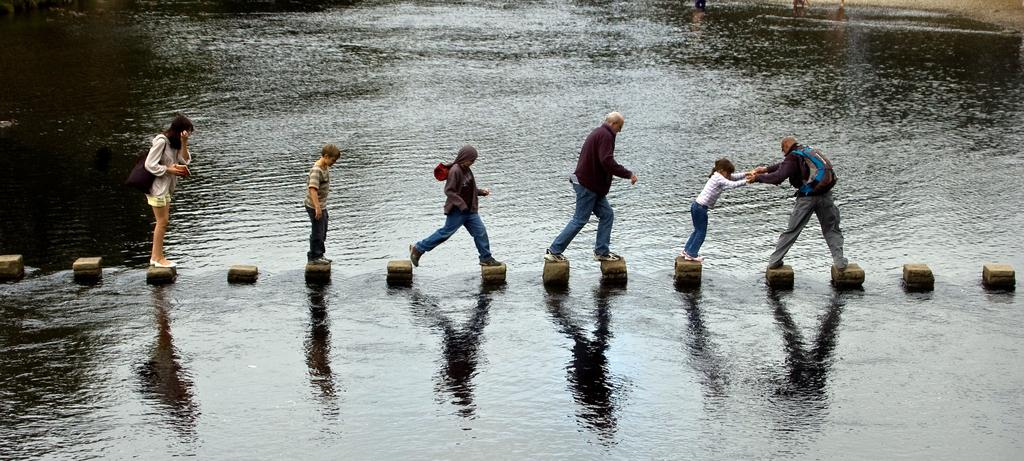How many people are in the image? There are persons in the image, but the exact number is not specified. What are the persons doing in the image? The persons are crossing water in the image. How are the persons crossing the water? The persons are using bricks arranged in the middle of the water to cross. What type of boundary can be seen in the image? There is no boundary present in the image; it features persons crossing water using bricks. What emotion can be seen on the faces of the persons in the image? The emotion of the persons in the image is not visible or described in the facts provided. 